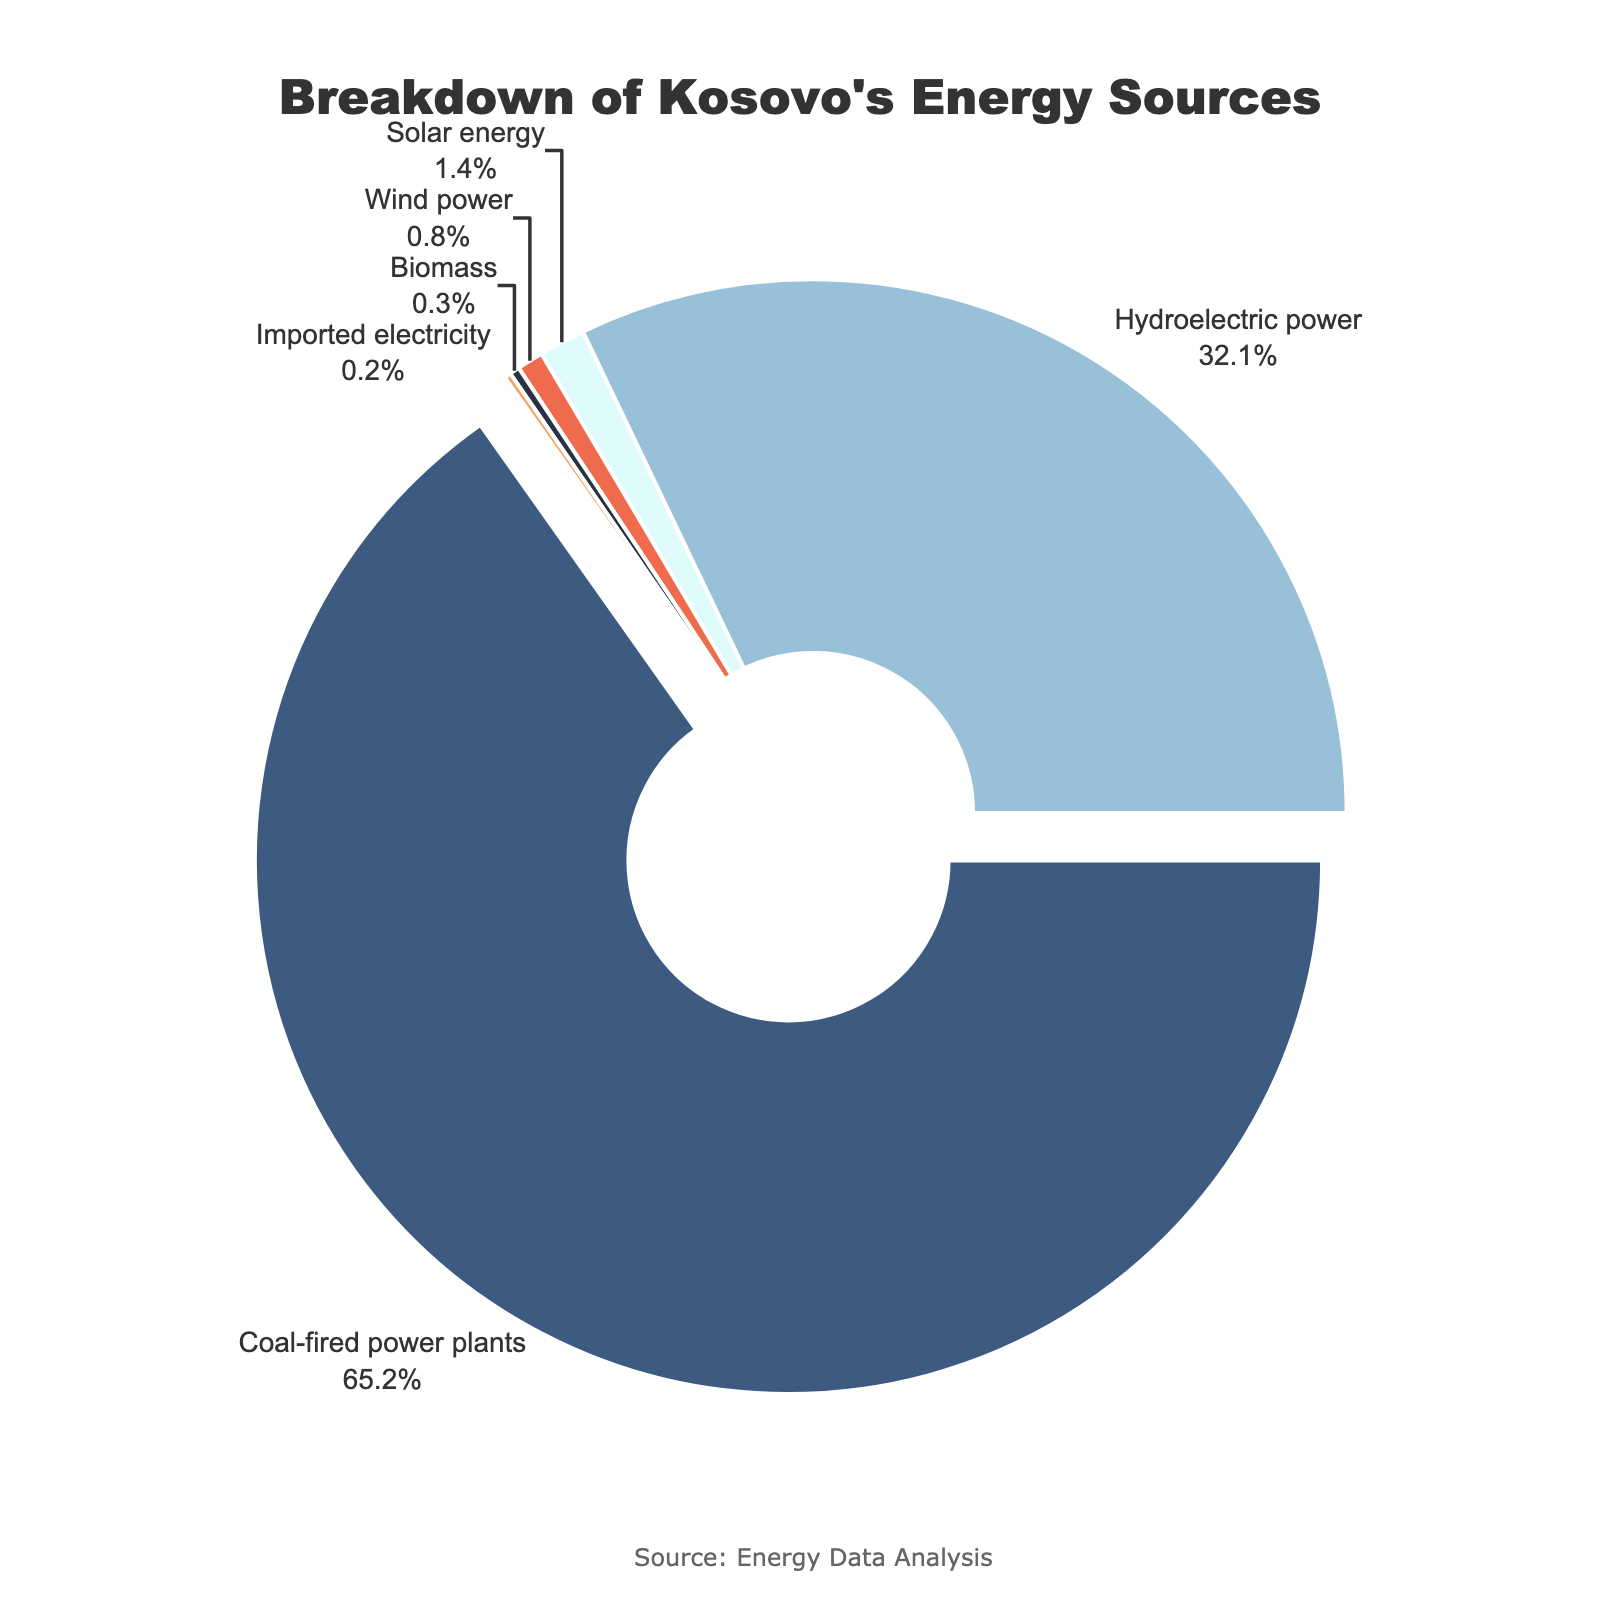What percentage of Kosovo's energy comes from renewable sources (hydroelectric power, solar energy, wind power, and biomass)? The renewable sources listed are hydroelectric power (32.1%), solar energy (1.4%), wind power (0.8%), and biomass (0.3%). Adding these percentages together, we get 32.1% + 1.4% + 0.8% + 0.3% = 34.6%.
Answer: 34.6% Which energy source contributes the most to Kosovo's energy production, and what is its percentage? By examining the pie chart, the largest segment represents coal-fired power plants, which contribute 65.2%.
Answer: Coal-fired power plants, 65.2% What is the combined percentage of solar energy and wind power? The percentages for solar energy and wind power are 1.4% and 0.8%, respectively. Adding these together gives 1.4% + 0.8% = 2.2%.
Answer: 2.2% How much more percentage does coal-fired power plants contribute than hydroelectric power? Coal-fired power plants contribute 65.2%, and hydroelectric power contributes 32.1%. The difference is 65.2% - 32.1% = 33.1%.
Answer: 33.1% Which energy sources contribute less than 1% to Kosovo's energy production? The pie chart segments indicate that solar energy (1.4%), wind power (0.8%), biomass (0.3%), and imported electricity (0.2%) contribute less than 1%.
Answer: Wind power, Biomass, Imported electricity Compare the contributions of biomass and imported electricity. Which one is higher and by how much? The contribution of biomass is 0.3%, while imported electricity is 0.2%. The difference is 0.3% - 0.2% = 0.1%.
Answer: Biomass, 0.1% What portion of Kosovo's energy is not derived from coal-fired power plants? The total contribution of coal-fired power plants is 65.2%. Hence, the remaining portion is 100% - 65.2% = 34.8%.
Answer: 34.8% By how many times does hydroelectric power's contribution exceed that of biomass? The contribution of hydroelectric power is 32.1%, and biomass is 0.3%. Dividing these gives 32.1 / 0.3 = 107.
Answer: 107 times Which energy source is represented by the smallest segment in the pie chart? The smallest segment in the pie chart corresponds to imported electricity, which is 0.2%.
Answer: Imported electricity 